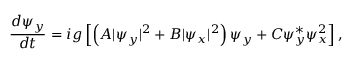<formula> <loc_0><loc_0><loc_500><loc_500>\frac { d \psi _ { y } } { d t } = i g \left [ \left ( A | \psi _ { y } | ^ { 2 } + B | \psi _ { x } | ^ { 2 } \right ) \psi _ { y } + C \psi _ { y } ^ { * } \psi _ { x } ^ { 2 } \right ] ,</formula> 